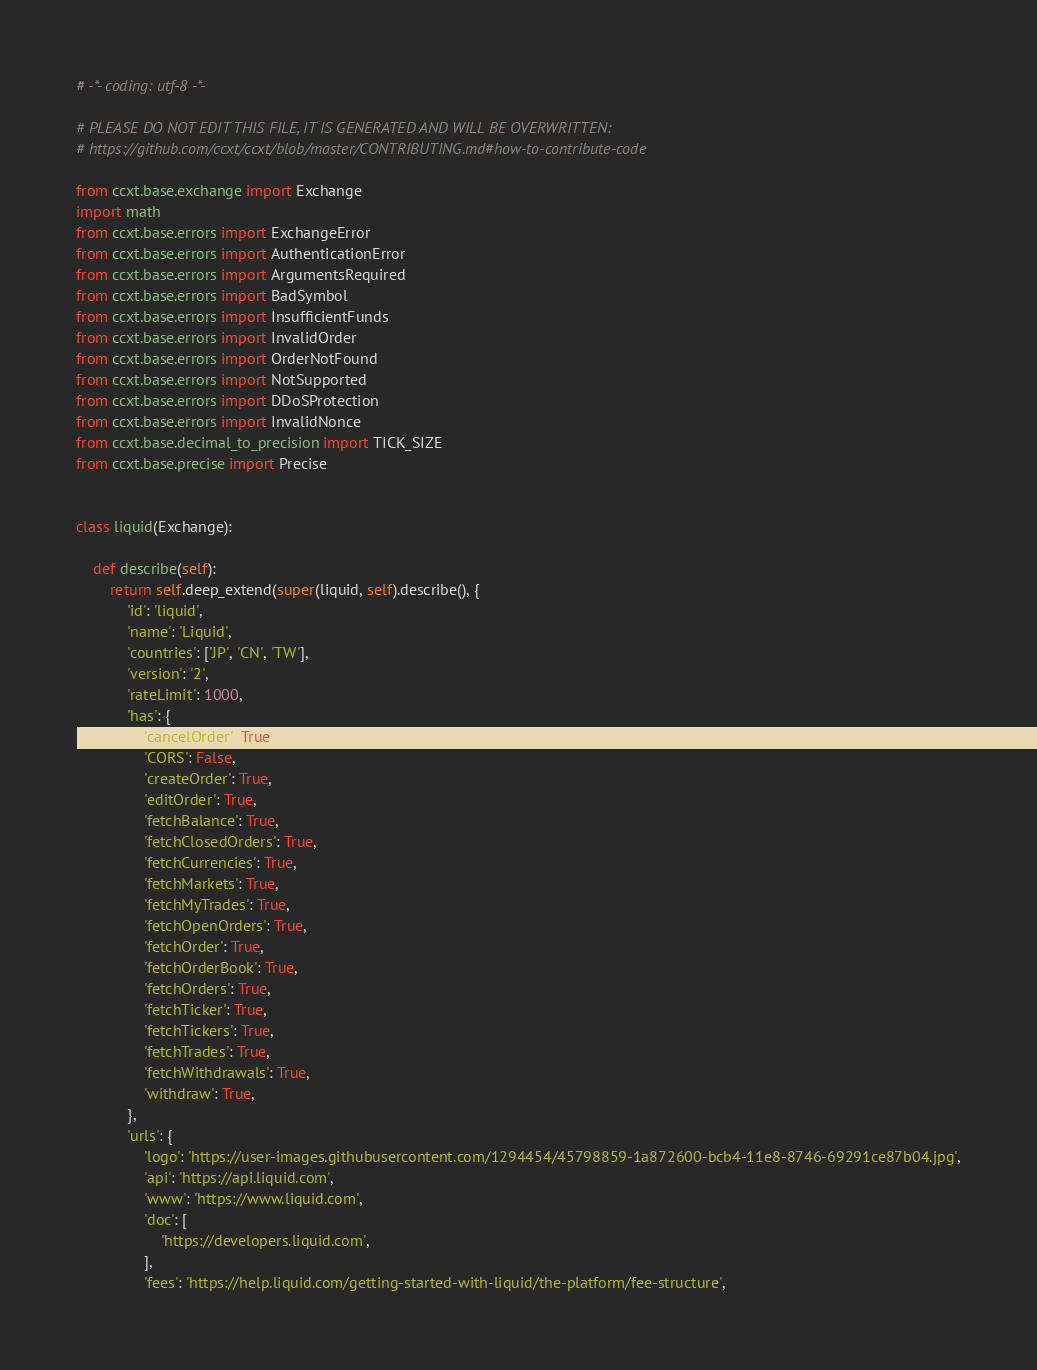Convert code to text. <code><loc_0><loc_0><loc_500><loc_500><_Python_># -*- coding: utf-8 -*-

# PLEASE DO NOT EDIT THIS FILE, IT IS GENERATED AND WILL BE OVERWRITTEN:
# https://github.com/ccxt/ccxt/blob/master/CONTRIBUTING.md#how-to-contribute-code

from ccxt.base.exchange import Exchange
import math
from ccxt.base.errors import ExchangeError
from ccxt.base.errors import AuthenticationError
from ccxt.base.errors import ArgumentsRequired
from ccxt.base.errors import BadSymbol
from ccxt.base.errors import InsufficientFunds
from ccxt.base.errors import InvalidOrder
from ccxt.base.errors import OrderNotFound
from ccxt.base.errors import NotSupported
from ccxt.base.errors import DDoSProtection
from ccxt.base.errors import InvalidNonce
from ccxt.base.decimal_to_precision import TICK_SIZE
from ccxt.base.precise import Precise


class liquid(Exchange):

    def describe(self):
        return self.deep_extend(super(liquid, self).describe(), {
            'id': 'liquid',
            'name': 'Liquid',
            'countries': ['JP', 'CN', 'TW'],
            'version': '2',
            'rateLimit': 1000,
            'has': {
                'cancelOrder': True,
                'CORS': False,
                'createOrder': True,
                'editOrder': True,
                'fetchBalance': True,
                'fetchClosedOrders': True,
                'fetchCurrencies': True,
                'fetchMarkets': True,
                'fetchMyTrades': True,
                'fetchOpenOrders': True,
                'fetchOrder': True,
                'fetchOrderBook': True,
                'fetchOrders': True,
                'fetchTicker': True,
                'fetchTickers': True,
                'fetchTrades': True,
                'fetchWithdrawals': True,
                'withdraw': True,
            },
            'urls': {
                'logo': 'https://user-images.githubusercontent.com/1294454/45798859-1a872600-bcb4-11e8-8746-69291ce87b04.jpg',
                'api': 'https://api.liquid.com',
                'www': 'https://www.liquid.com',
                'doc': [
                    'https://developers.liquid.com',
                ],
                'fees': 'https://help.liquid.com/getting-started-with-liquid/the-platform/fee-structure',</code> 